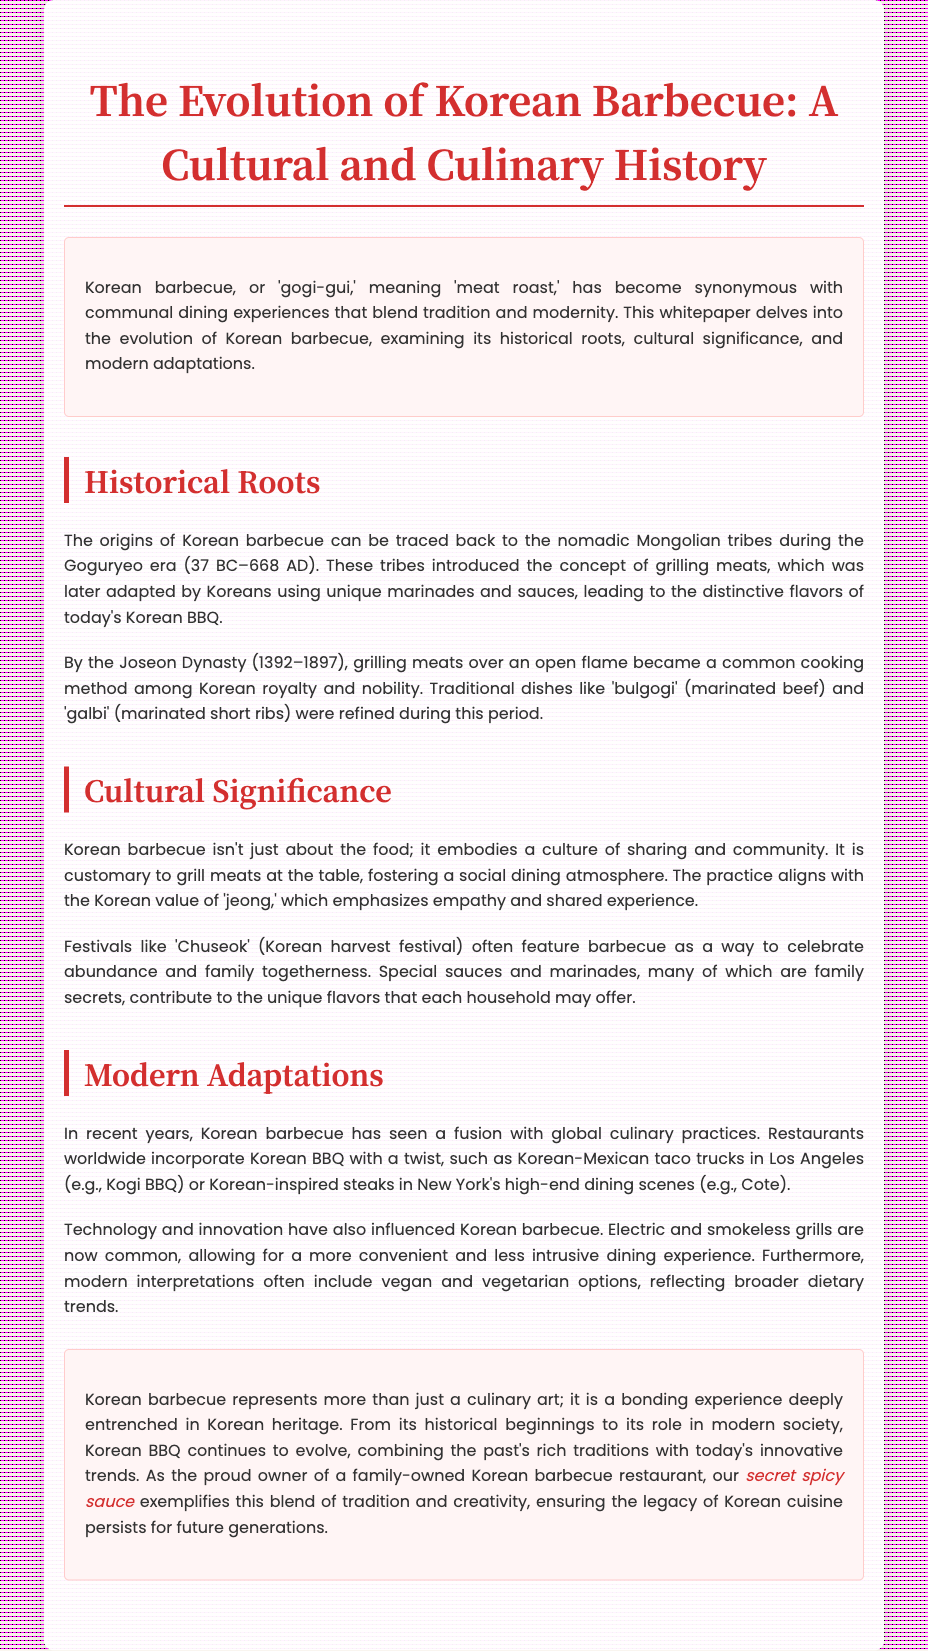what does 'gogi-gui' mean? The term 'gogi-gui' translates to 'meat roast' and refers to Korean barbecue.
Answer: 'meat roast' which era introduced the concept of grilling meats? The nomadic Mongolian tribes introduced grilling meats during the Goguryeo era.
Answer: Goguryeo era what traditional dish was refined during the Joseon Dynasty? Traditional dishes like 'bulgogi' and 'galbi' were refined during the Joseon Dynasty.
Answer: bulgogi, galbi what cultural value does Korean barbecue align with? The practice of grilling at the table aligns with the Korean value of 'jeong', emphasizing empathy and shared experience.
Answer: jeong what is a modern adaptation of Korean barbecue mentioned? Korean barbecue has fused with global culinary practices like Korean-Mexican tacos and high-end Korean-inspired steaks.
Answer: fusion with global culinary practices what is the purpose of the conclusion section in the document? The conclusion summarizes the significance of Korean barbecue and emphasizes its evolution and cultural relevance.
Answer: summarizes the significance what is the unique aspect of the family restaurant mentioned? The family-owned restaurant has a secret spicy sauce that adds uniqueness to their offerings.
Answer: secret spicy sauce which festival features barbecue as a way to celebrate? The 'Chuseok' festival features barbecue as a means of celebrating abundance and family togetherness.
Answer: Chuseok 